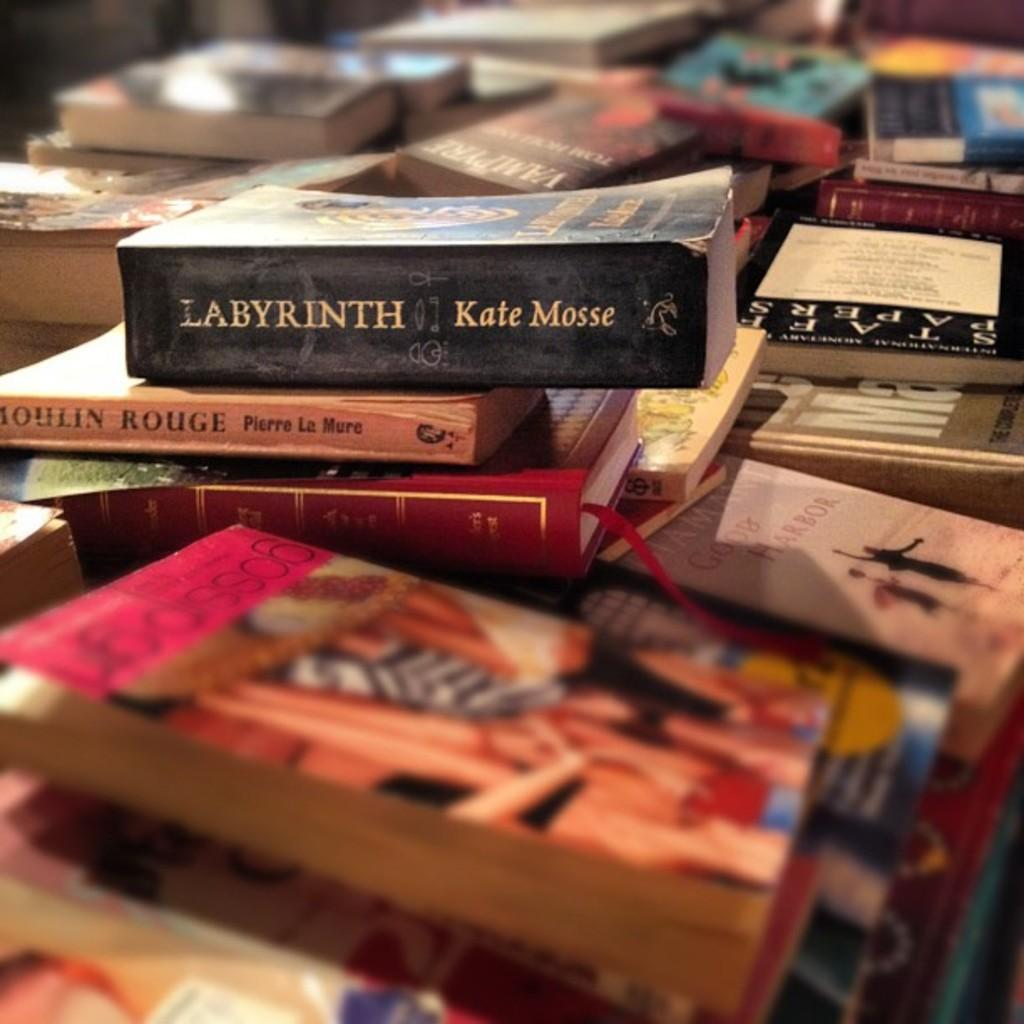<image>
Relay a brief, clear account of the picture shown. books on top of books with the book 'labryinth' on the top 